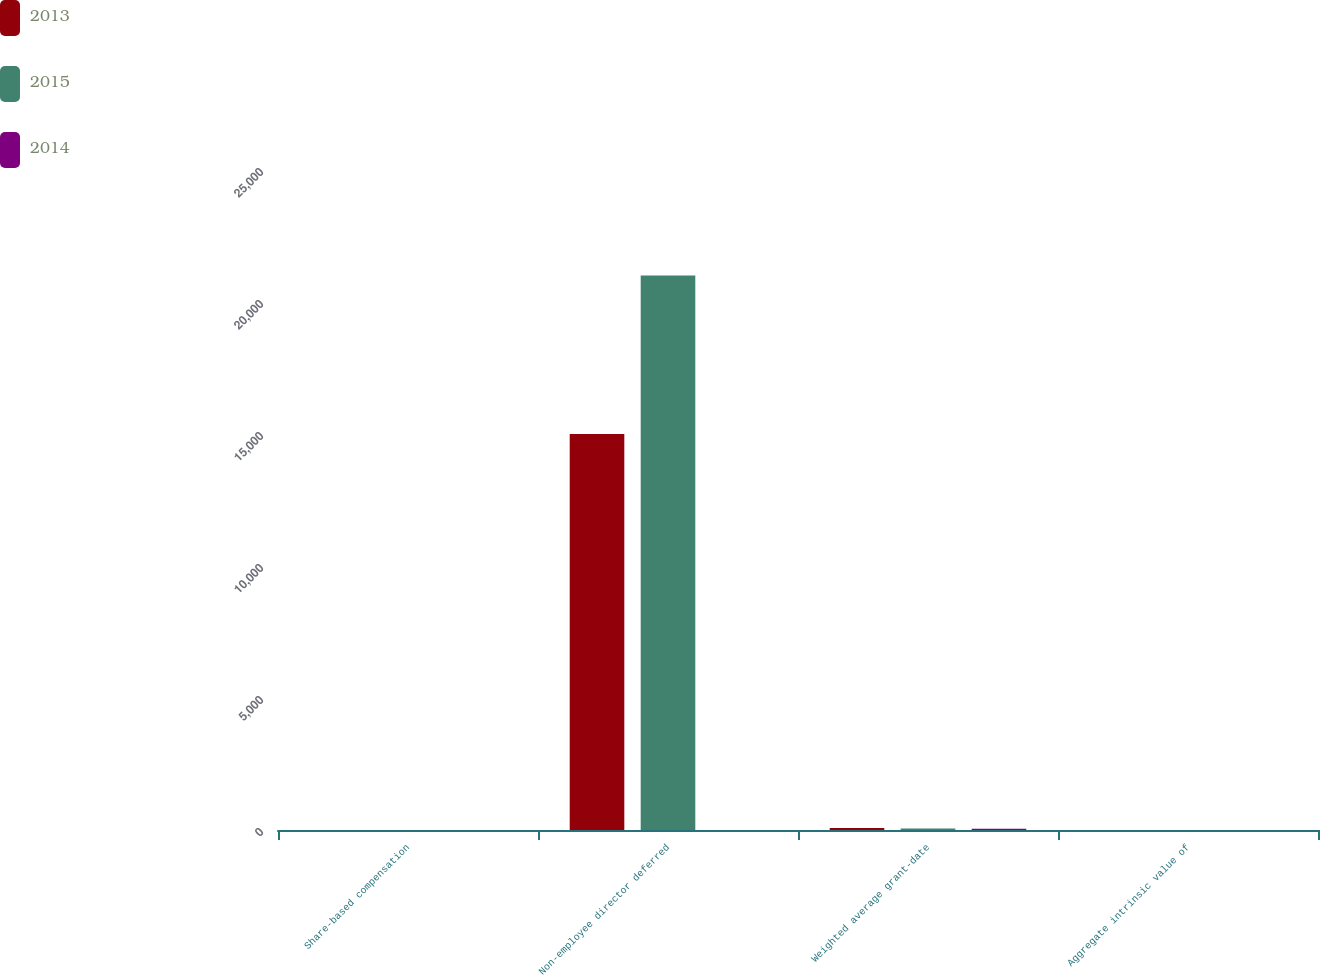<chart> <loc_0><loc_0><loc_500><loc_500><stacked_bar_chart><ecel><fcel>Share-based compensation<fcel>Non-employee director deferred<fcel>Weighted average grant-date<fcel>Aggregate intrinsic value of<nl><fcel>2013<fcel>1.1<fcel>15000<fcel>80<fcel>1.8<nl><fcel>2015<fcel>1.2<fcel>21000<fcel>59<fcel>0.8<nl><fcel>2014<fcel>1.4<fcel>1.8<fcel>44<fcel>0.7<nl></chart> 